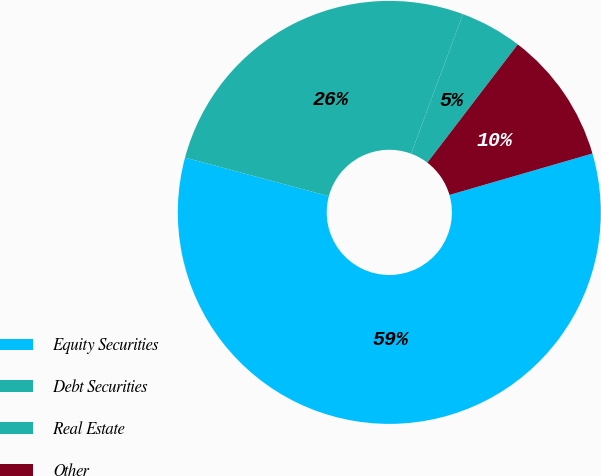<chart> <loc_0><loc_0><loc_500><loc_500><pie_chart><fcel>Equity Securities<fcel>Debt Securities<fcel>Real Estate<fcel>Other<nl><fcel>58.66%<fcel>26.49%<fcel>4.73%<fcel>10.12%<nl></chart> 